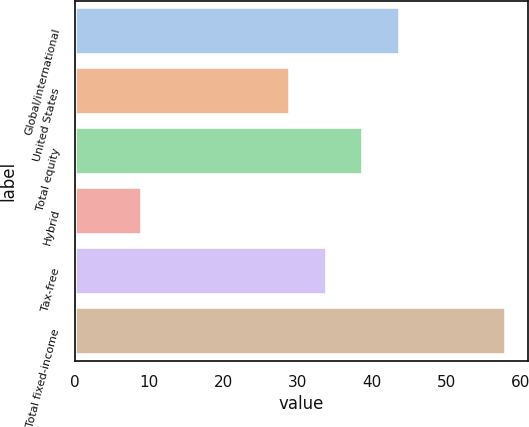<chart> <loc_0><loc_0><loc_500><loc_500><bar_chart><fcel>Global/international<fcel>United States<fcel>Total equity<fcel>Hybrid<fcel>Tax-free<fcel>Total fixed-income<nl><fcel>43.7<fcel>29<fcel>38.8<fcel>9<fcel>33.9<fcel>58<nl></chart> 